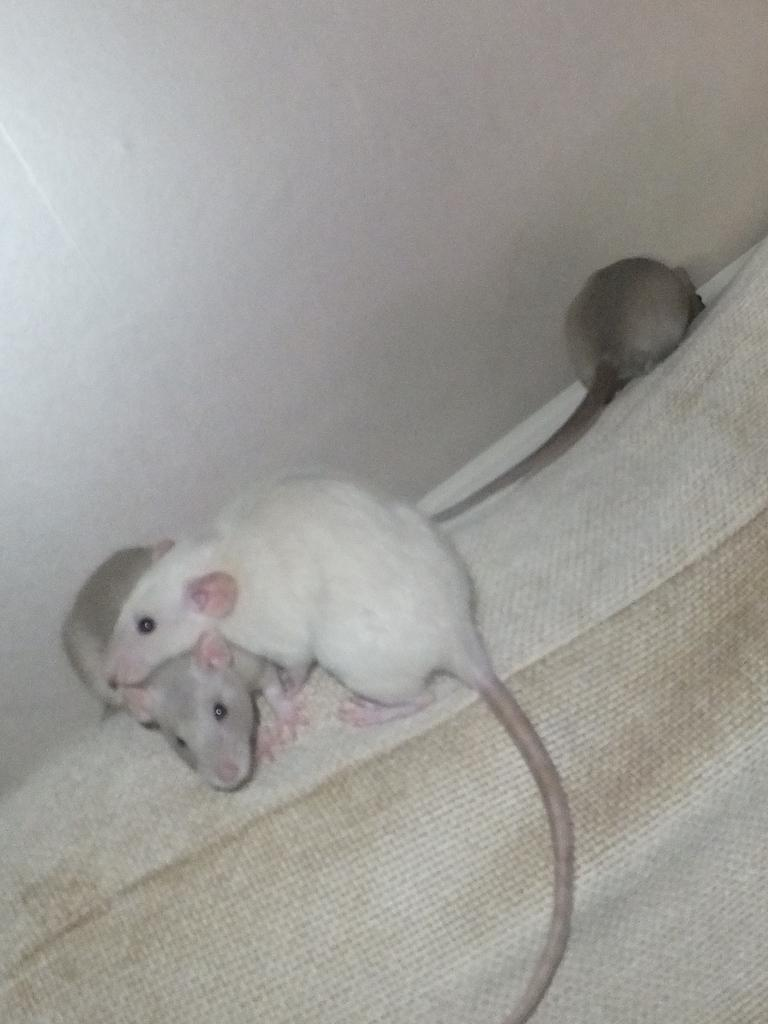How many rats are present in the image? There are three rats in the image. What are the rats doing in the image? The rats are on a cat. What can be seen in the background of the image? There is a wall in the image. What is the color of the wall? The wall is white in color. What type of box is being used to cause the rats to wear apparel in the image? There is no box, cause, or apparel present in the image; it only features three rats on a cat and a white wall in the background. 